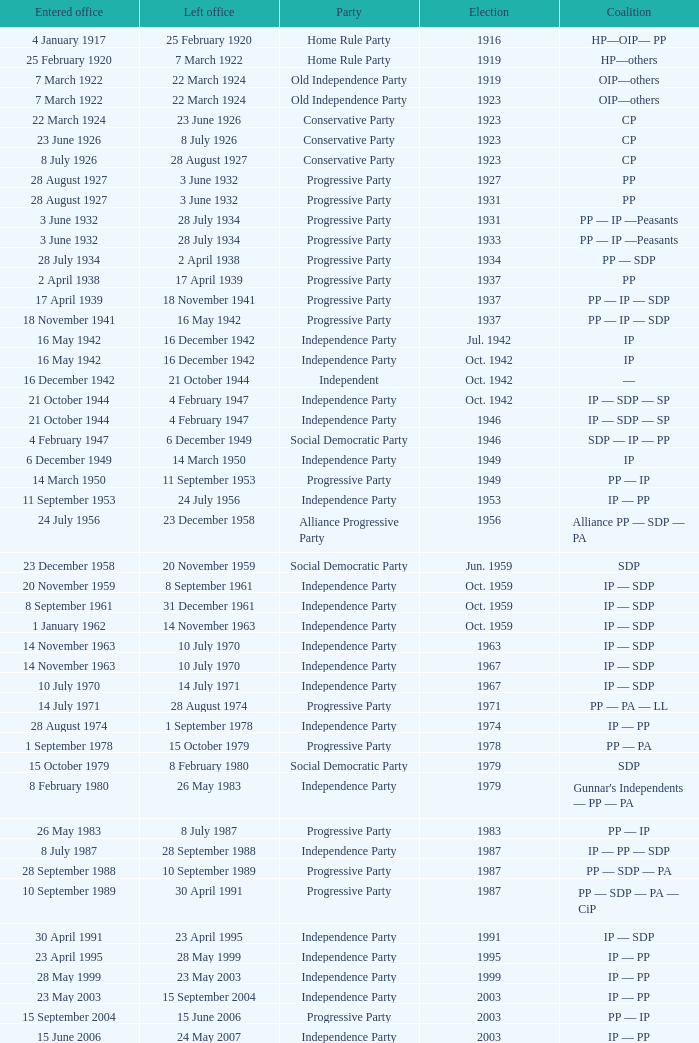When did the party elected in jun. 1959 enter office? 23 December 1958. 